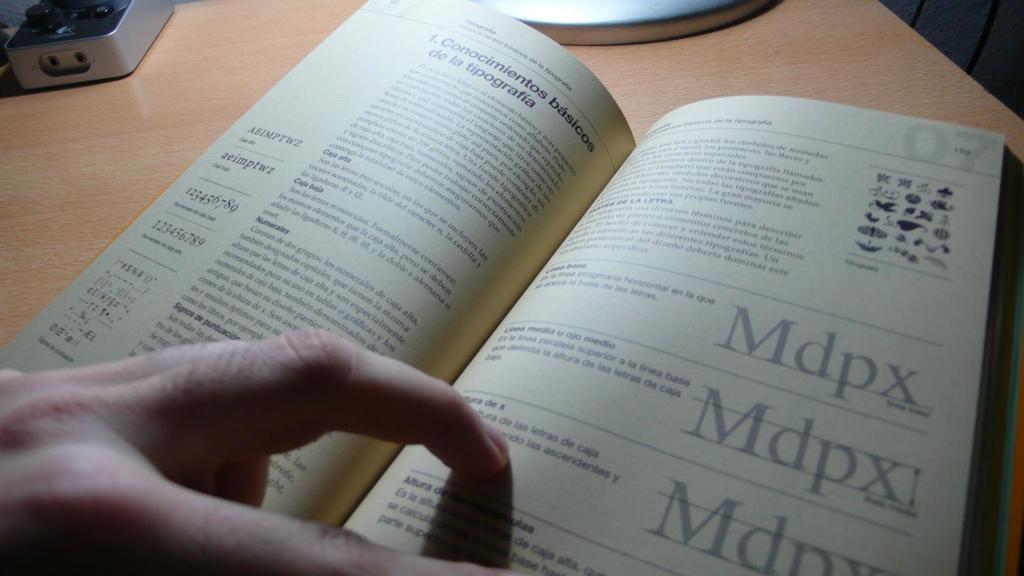Are they on page 07?
Your response must be concise. Yes. What four letters are written over and over in a very large font?
Offer a terse response. Mdpx. 